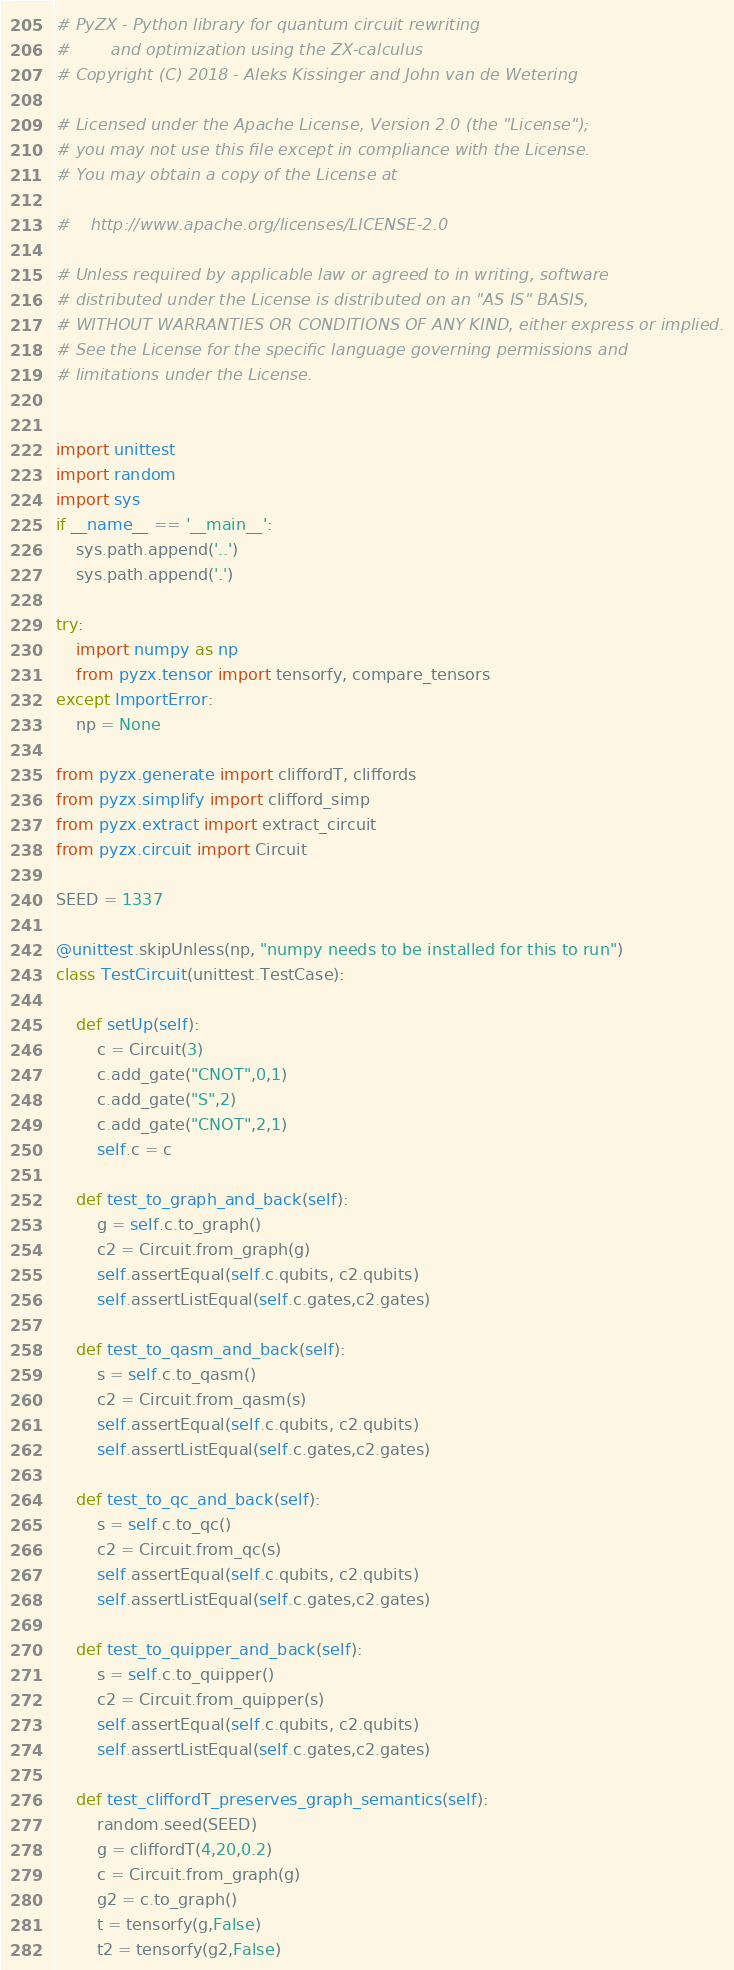<code> <loc_0><loc_0><loc_500><loc_500><_Python_># PyZX - Python library for quantum circuit rewriting 
#        and optimization using the ZX-calculus
# Copyright (C) 2018 - Aleks Kissinger and John van de Wetering

# Licensed under the Apache License, Version 2.0 (the "License");
# you may not use this file except in compliance with the License.
# You may obtain a copy of the License at

#    http://www.apache.org/licenses/LICENSE-2.0

# Unless required by applicable law or agreed to in writing, software
# distributed under the License is distributed on an "AS IS" BASIS,
# WITHOUT WARRANTIES OR CONDITIONS OF ANY KIND, either express or implied.
# See the License for the specific language governing permissions and
# limitations under the License.


import unittest
import random
import sys
if __name__ == '__main__':
    sys.path.append('..')
    sys.path.append('.')

try:
    import numpy as np
    from pyzx.tensor import tensorfy, compare_tensors
except ImportError:
    np = None

from pyzx.generate import cliffordT, cliffords
from pyzx.simplify import clifford_simp
from pyzx.extract import extract_circuit
from pyzx.circuit import Circuit

SEED = 1337

@unittest.skipUnless(np, "numpy needs to be installed for this to run")
class TestCircuit(unittest.TestCase):

    def setUp(self):
        c = Circuit(3)
        c.add_gate("CNOT",0,1)
        c.add_gate("S",2)
        c.add_gate("CNOT",2,1)
        self.c = c

    def test_to_graph_and_back(self):
        g = self.c.to_graph()
        c2 = Circuit.from_graph(g)
        self.assertEqual(self.c.qubits, c2.qubits)
        self.assertListEqual(self.c.gates,c2.gates)

    def test_to_qasm_and_back(self):
        s = self.c.to_qasm()
        c2 = Circuit.from_qasm(s)
        self.assertEqual(self.c.qubits, c2.qubits)
        self.assertListEqual(self.c.gates,c2.gates)

    def test_to_qc_and_back(self):
        s = self.c.to_qc()
        c2 = Circuit.from_qc(s)
        self.assertEqual(self.c.qubits, c2.qubits)
        self.assertListEqual(self.c.gates,c2.gates)

    def test_to_quipper_and_back(self):
        s = self.c.to_quipper()
        c2 = Circuit.from_quipper(s)
        self.assertEqual(self.c.qubits, c2.qubits)
        self.assertListEqual(self.c.gates,c2.gates)

    def test_cliffordT_preserves_graph_semantics(self):
        random.seed(SEED)
        g = cliffordT(4,20,0.2)
        c = Circuit.from_graph(g)
        g2 = c.to_graph()
        t = tensorfy(g,False)
        t2 = tensorfy(g2,False)</code> 